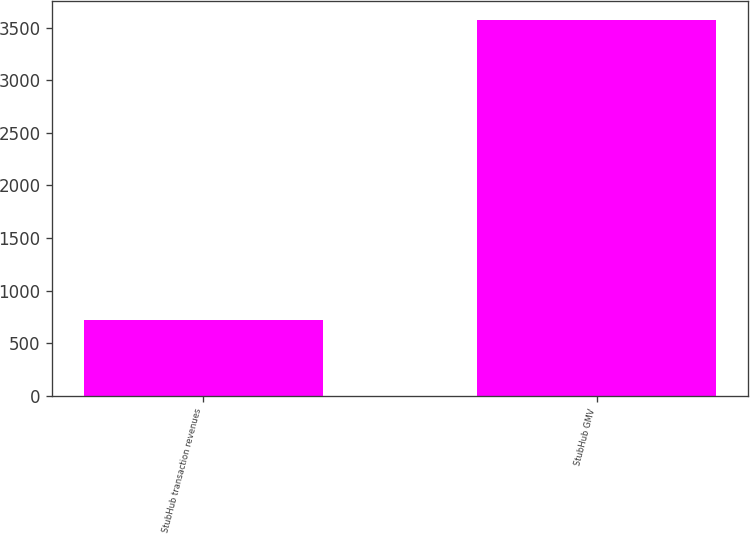<chart> <loc_0><loc_0><loc_500><loc_500><bar_chart><fcel>StubHub transaction revenues<fcel>StubHub GMV<nl><fcel>725<fcel>3574<nl></chart> 